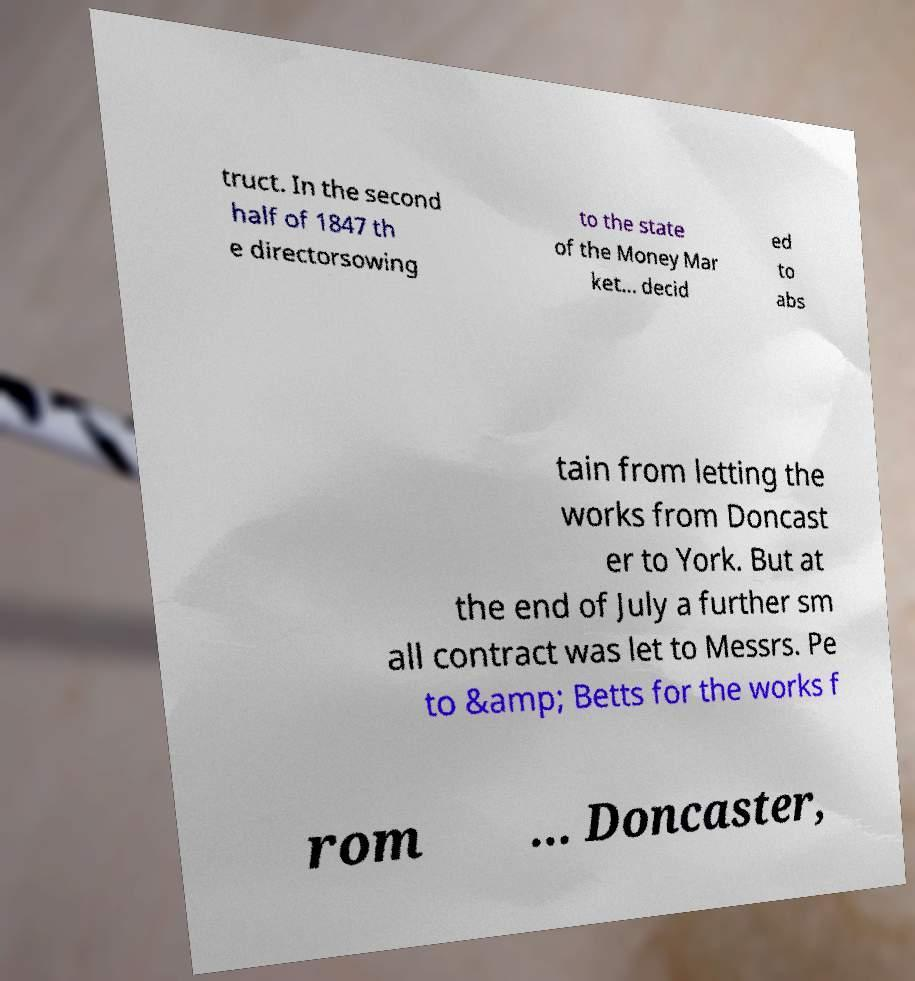What messages or text are displayed in this image? I need them in a readable, typed format. truct. In the second half of 1847 th e directorsowing to the state of the Money Mar ket... decid ed to abs tain from letting the works from Doncast er to York. But at the end of July a further sm all contract was let to Messrs. Pe to &amp; Betts for the works f rom ... Doncaster, 